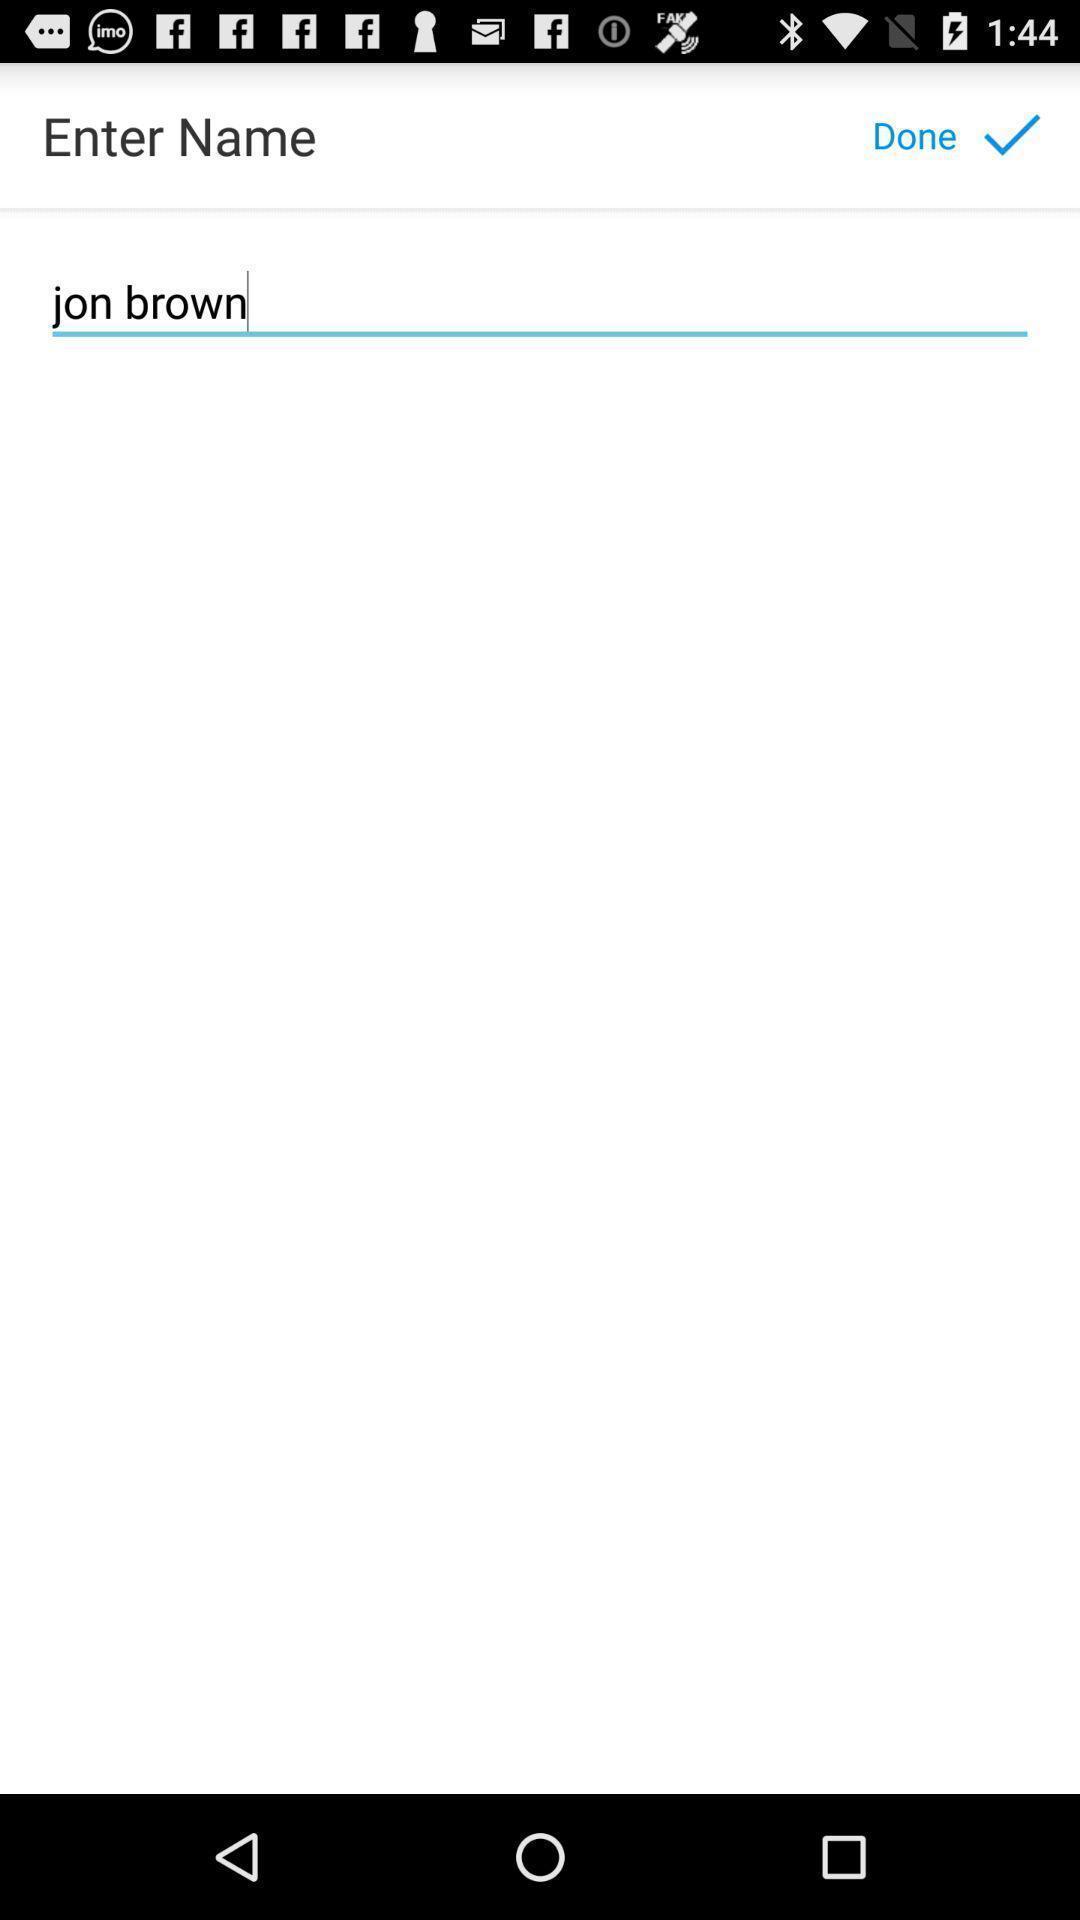Describe the visual elements of this screenshot. Screen shows enter name. 